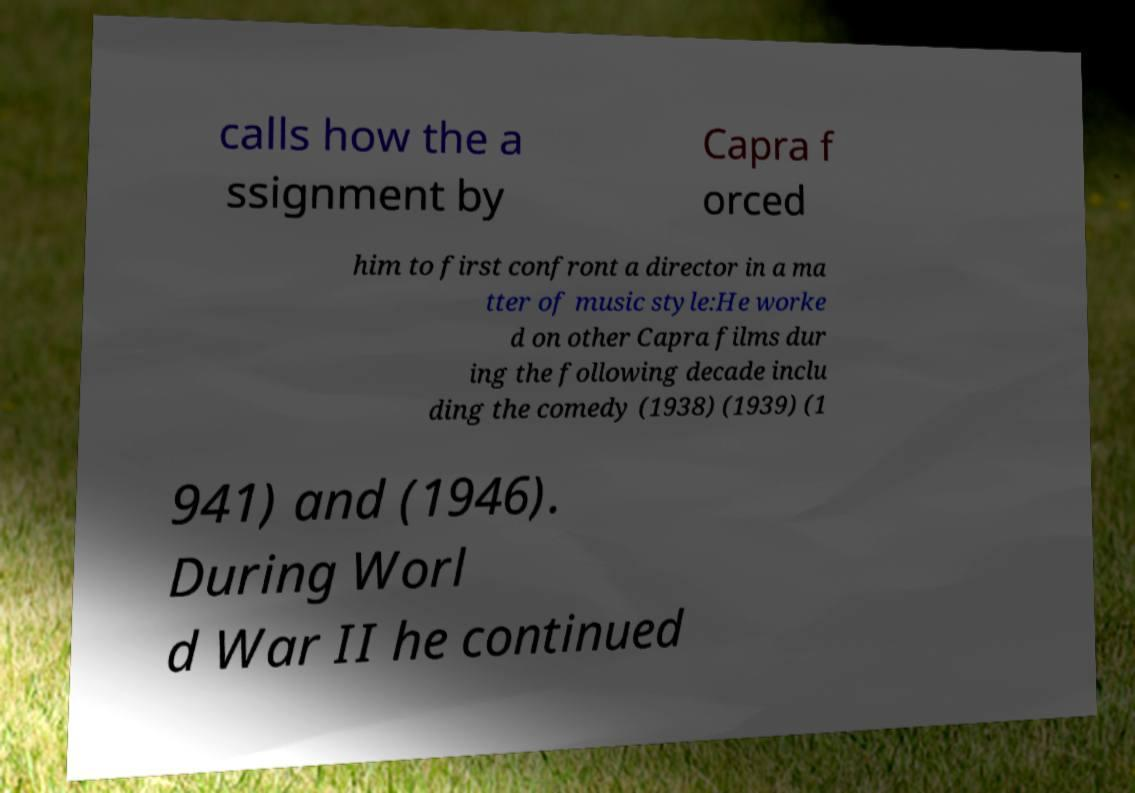Can you accurately transcribe the text from the provided image for me? calls how the a ssignment by Capra f orced him to first confront a director in a ma tter of music style:He worke d on other Capra films dur ing the following decade inclu ding the comedy (1938) (1939) (1 941) and (1946). During Worl d War II he continued 